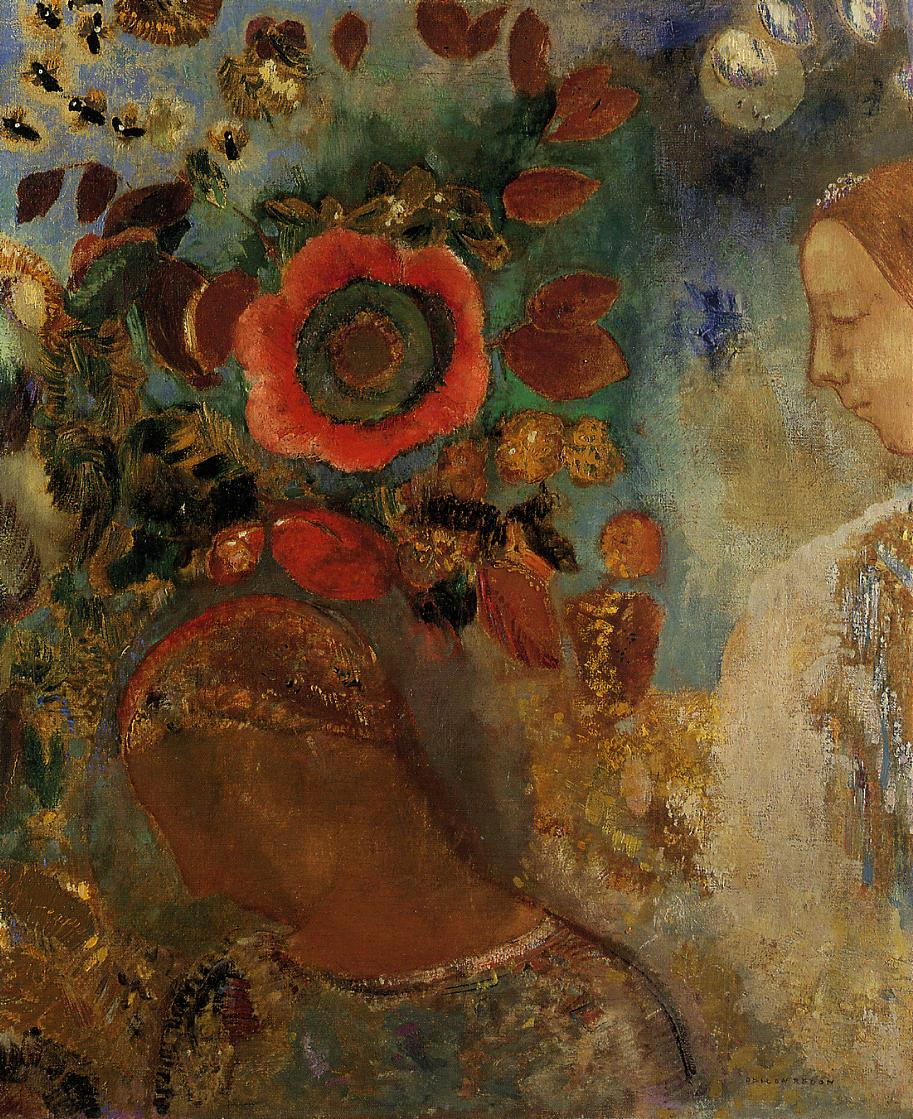Could you tell me more about the artistic techniques used in this painting? Certainly, this painting utilizes a variety of impressionistic techniques. The brushstrokes are loose and fluid, conveying movement and life. Color is used not just to describe the form, but also to play with light and evoke mood. Interestingly, there's a lack of focus on detailed facial features, instead opting to blend the subject with her surroundings, which highlights the theme of being at one with the environment. 